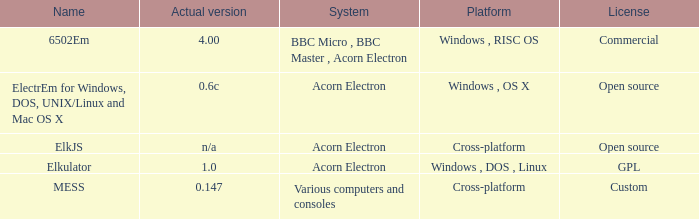What is the system called that is named ELKJS? Acorn Electron. 